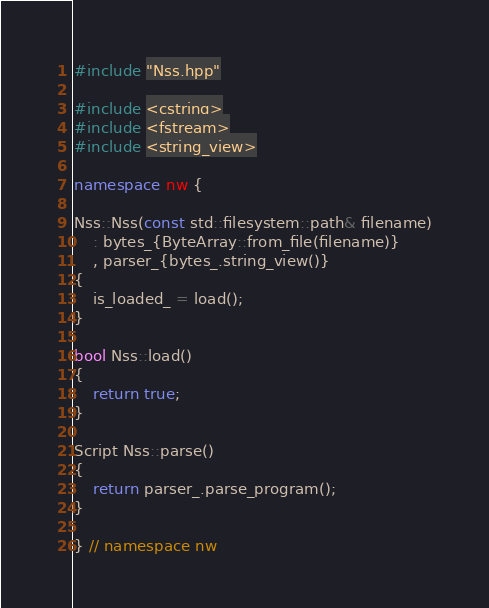<code> <loc_0><loc_0><loc_500><loc_500><_C++_>#include "Nss.hpp"

#include <cstring>
#include <fstream>
#include <string_view>

namespace nw {

Nss::Nss(const std::filesystem::path& filename)
    : bytes_{ByteArray::from_file(filename)}
    , parser_{bytes_.string_view()}
{
    is_loaded_ = load();
}

bool Nss::load()
{
    return true;
}

Script Nss::parse()
{
    return parser_.parse_program();
}

} // namespace nw
</code> 